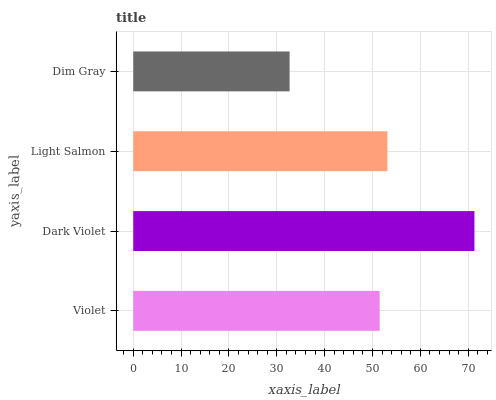Is Dim Gray the minimum?
Answer yes or no. Yes. Is Dark Violet the maximum?
Answer yes or no. Yes. Is Light Salmon the minimum?
Answer yes or no. No. Is Light Salmon the maximum?
Answer yes or no. No. Is Dark Violet greater than Light Salmon?
Answer yes or no. Yes. Is Light Salmon less than Dark Violet?
Answer yes or no. Yes. Is Light Salmon greater than Dark Violet?
Answer yes or no. No. Is Dark Violet less than Light Salmon?
Answer yes or no. No. Is Light Salmon the high median?
Answer yes or no. Yes. Is Violet the low median?
Answer yes or no. Yes. Is Dark Violet the high median?
Answer yes or no. No. Is Dark Violet the low median?
Answer yes or no. No. 